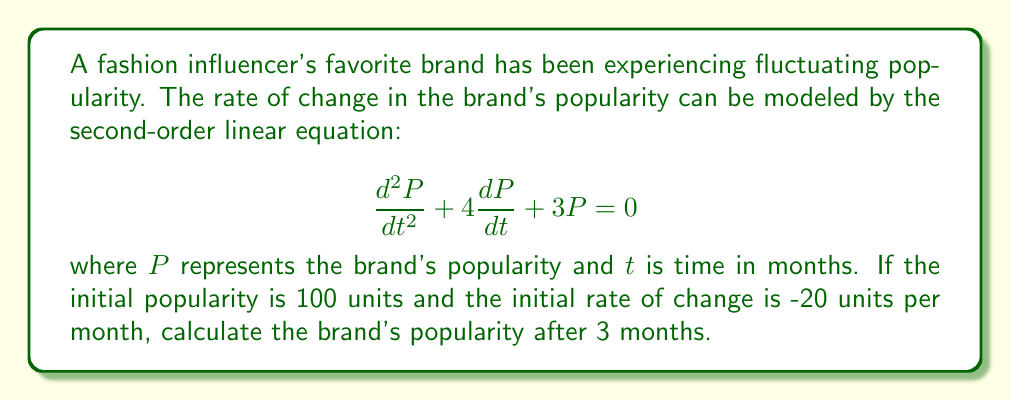Teach me how to tackle this problem. To solve this problem, we need to follow these steps:

1) The general solution for this second-order linear equation is:
   $$P(t) = C_1e^{-t} + C_2e^{-3t}$$

2) We need to find $C_1$ and $C_2$ using the initial conditions:
   At $t=0$, $P(0) = 100$ and $\frac{dP}{dt}(0) = -20$

3) Using the first condition:
   $$P(0) = C_1 + C_2 = 100$$

4) For the second condition, we differentiate $P(t)$:
   $$\frac{dP}{dt} = -C_1e^{-t} - 3C_2e^{-3t}$$
   At $t=0$: $-C_1 - 3C_2 = -20$

5) Now we have a system of equations:
   $$C_1 + C_2 = 100$$
   $$C_1 + 3C_2 = 20$$

6) Solving this system:
   Subtracting the second equation from the first:
   $$-2C_2 = 80$$
   $$C_2 = -40$$
   $$C_1 = 140$$

7) Therefore, the particular solution is:
   $$P(t) = 140e^{-t} - 40e^{-3t}$$

8) To find the popularity after 3 months, we calculate $P(3)$:
   $$P(3) = 140e^{-3} - 40e^{-9}$$
   $$\approx 140(0.0498) - 40(0.0001)$$
   $$\approx 6.972 - 0.004$$
   $$\approx 6.968$$
Answer: The brand's popularity after 3 months will be approximately 6.968 units. 